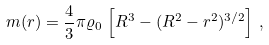<formula> <loc_0><loc_0><loc_500><loc_500>m ( r ) = \frac { 4 } { 3 } \pi \varrho _ { 0 } \, \left [ R ^ { 3 } - ( R ^ { 2 } - r ^ { 2 } ) ^ { 3 / 2 } \right ] \, ,</formula> 